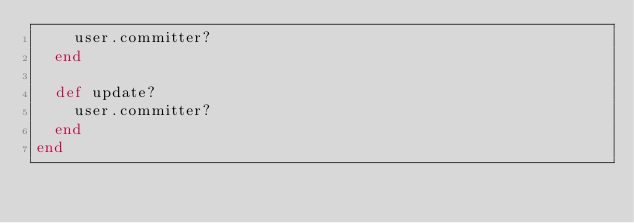Convert code to text. <code><loc_0><loc_0><loc_500><loc_500><_Ruby_>    user.committer?
  end

  def update?
    user.committer?
  end
end
</code> 